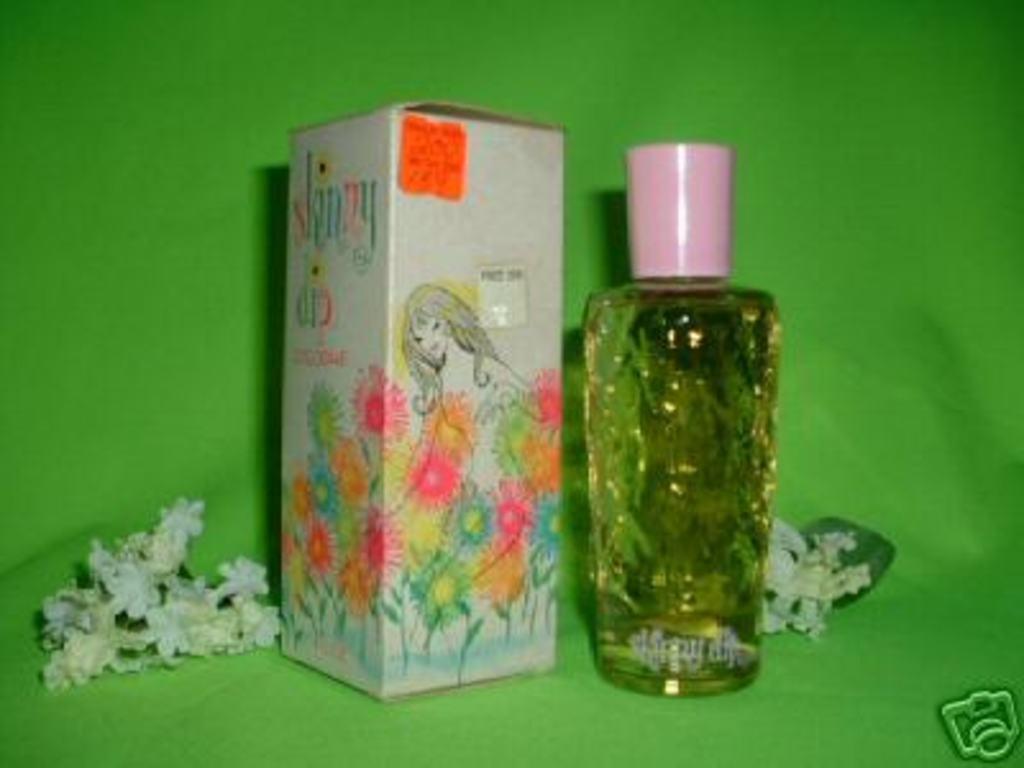What type of nude swimming action is this product named after?
Give a very brief answer. Skinny dip. 